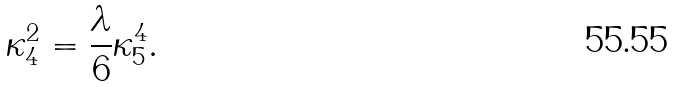Convert formula to latex. <formula><loc_0><loc_0><loc_500><loc_500>\kappa ^ { 2 } _ { 4 } = \frac { \lambda } { 6 } \kappa ^ { 4 } _ { 5 } .</formula> 